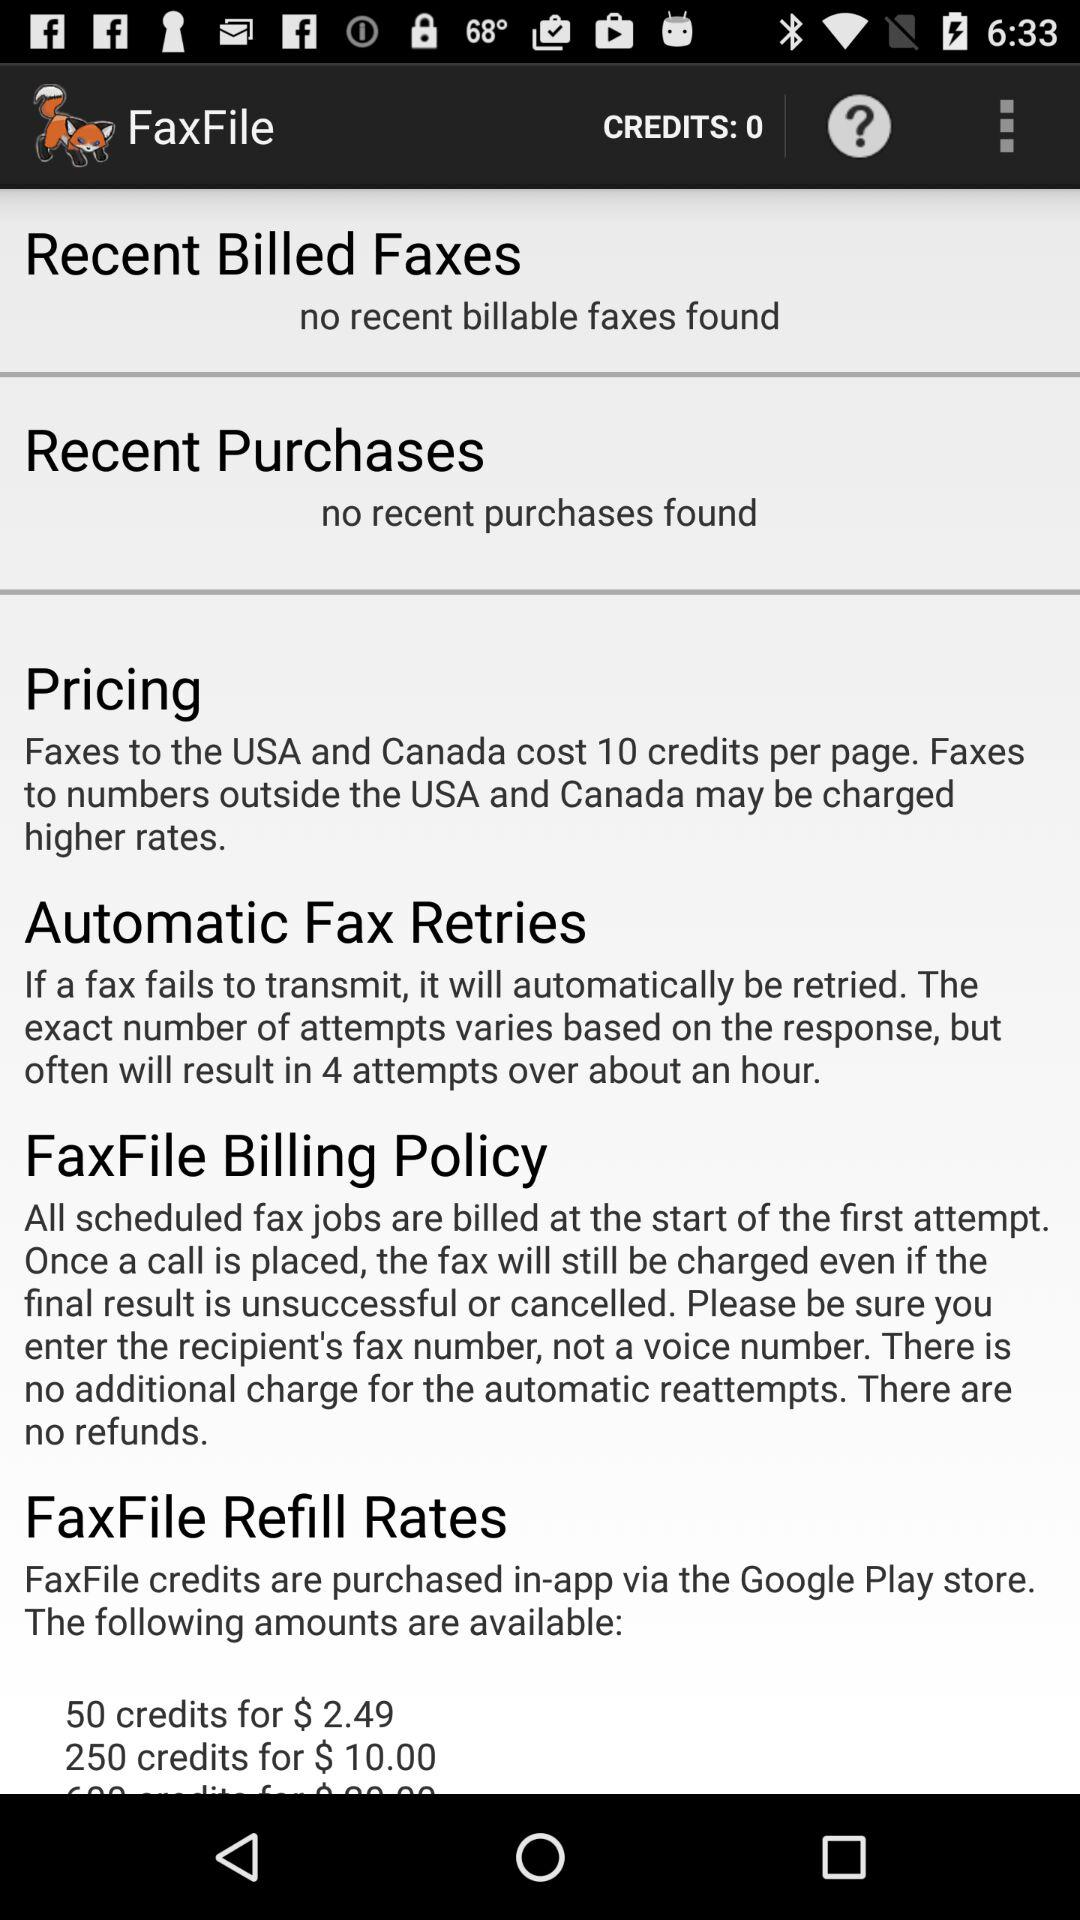What is the price for 50 credits? The price for 50 credits is $2.49. 